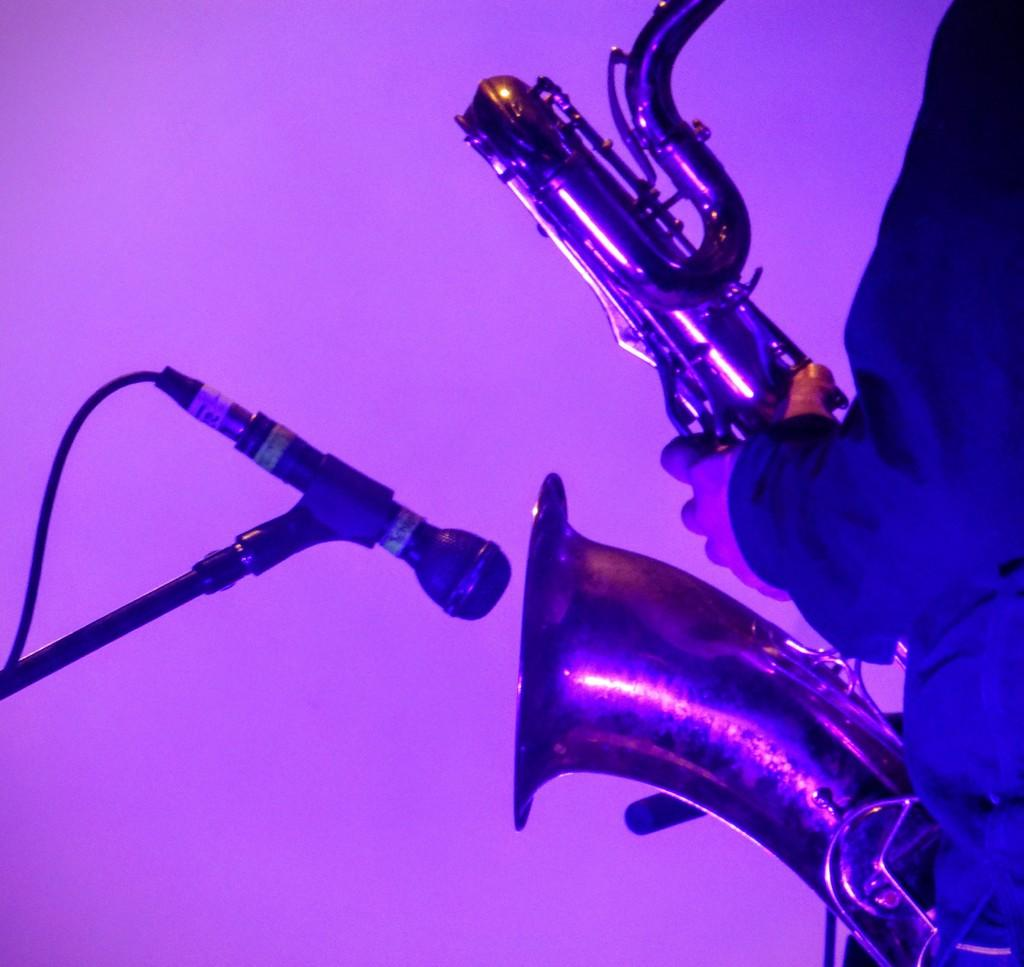What is the main subject of the image? The main subject of the image is a man. What is the man holding in the image? The man is holding a musical instrument. What can be seen on the left side of the image? There is a microphone on the left side of the image. Where is the coal stored in the image? There is no coal present in the image. What type of crib is visible in the image? There is no crib present in the image. 